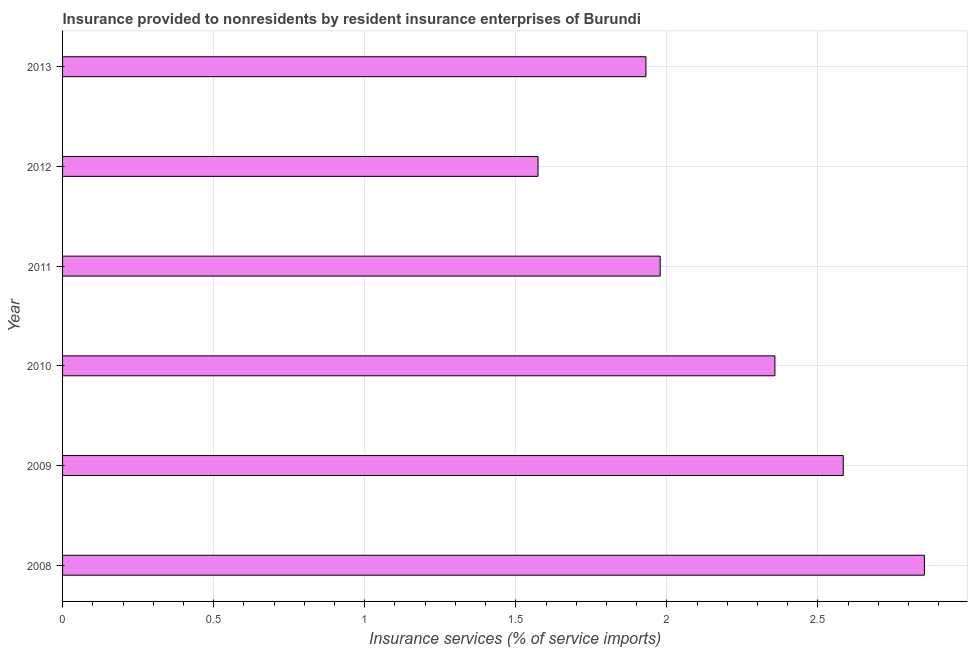Does the graph contain any zero values?
Your response must be concise. No. Does the graph contain grids?
Provide a short and direct response. Yes. What is the title of the graph?
Give a very brief answer. Insurance provided to nonresidents by resident insurance enterprises of Burundi. What is the label or title of the X-axis?
Offer a terse response. Insurance services (% of service imports). What is the label or title of the Y-axis?
Offer a terse response. Year. What is the insurance and financial services in 2010?
Provide a short and direct response. 2.36. Across all years, what is the maximum insurance and financial services?
Offer a very short reply. 2.85. Across all years, what is the minimum insurance and financial services?
Keep it short and to the point. 1.57. In which year was the insurance and financial services minimum?
Keep it short and to the point. 2012. What is the sum of the insurance and financial services?
Ensure brevity in your answer.  13.28. What is the difference between the insurance and financial services in 2008 and 2012?
Provide a succinct answer. 1.28. What is the average insurance and financial services per year?
Ensure brevity in your answer.  2.21. What is the median insurance and financial services?
Ensure brevity in your answer.  2.17. In how many years, is the insurance and financial services greater than 2.4 %?
Offer a terse response. 2. What is the ratio of the insurance and financial services in 2008 to that in 2013?
Provide a succinct answer. 1.48. Is the insurance and financial services in 2009 less than that in 2010?
Your answer should be compact. No. Is the difference between the insurance and financial services in 2009 and 2012 greater than the difference between any two years?
Keep it short and to the point. No. What is the difference between the highest and the second highest insurance and financial services?
Offer a terse response. 0.27. Is the sum of the insurance and financial services in 2009 and 2012 greater than the maximum insurance and financial services across all years?
Your answer should be very brief. Yes. What is the difference between the highest and the lowest insurance and financial services?
Ensure brevity in your answer.  1.28. In how many years, is the insurance and financial services greater than the average insurance and financial services taken over all years?
Your answer should be compact. 3. How many years are there in the graph?
Your answer should be very brief. 6. Are the values on the major ticks of X-axis written in scientific E-notation?
Provide a short and direct response. No. What is the Insurance services (% of service imports) in 2008?
Give a very brief answer. 2.85. What is the Insurance services (% of service imports) of 2009?
Make the answer very short. 2.58. What is the Insurance services (% of service imports) of 2010?
Your answer should be very brief. 2.36. What is the Insurance services (% of service imports) of 2011?
Provide a succinct answer. 1.98. What is the Insurance services (% of service imports) of 2012?
Your answer should be very brief. 1.57. What is the Insurance services (% of service imports) of 2013?
Your response must be concise. 1.93. What is the difference between the Insurance services (% of service imports) in 2008 and 2009?
Your response must be concise. 0.27. What is the difference between the Insurance services (% of service imports) in 2008 and 2010?
Ensure brevity in your answer.  0.49. What is the difference between the Insurance services (% of service imports) in 2008 and 2011?
Your answer should be very brief. 0.87. What is the difference between the Insurance services (% of service imports) in 2008 and 2012?
Provide a succinct answer. 1.28. What is the difference between the Insurance services (% of service imports) in 2008 and 2013?
Provide a short and direct response. 0.92. What is the difference between the Insurance services (% of service imports) in 2009 and 2010?
Your response must be concise. 0.23. What is the difference between the Insurance services (% of service imports) in 2009 and 2011?
Your answer should be very brief. 0.61. What is the difference between the Insurance services (% of service imports) in 2009 and 2012?
Offer a very short reply. 1.01. What is the difference between the Insurance services (% of service imports) in 2009 and 2013?
Offer a very short reply. 0.65. What is the difference between the Insurance services (% of service imports) in 2010 and 2011?
Ensure brevity in your answer.  0.38. What is the difference between the Insurance services (% of service imports) in 2010 and 2012?
Offer a very short reply. 0.78. What is the difference between the Insurance services (% of service imports) in 2010 and 2013?
Offer a terse response. 0.43. What is the difference between the Insurance services (% of service imports) in 2011 and 2012?
Give a very brief answer. 0.4. What is the difference between the Insurance services (% of service imports) in 2011 and 2013?
Your answer should be very brief. 0.05. What is the difference between the Insurance services (% of service imports) in 2012 and 2013?
Offer a terse response. -0.36. What is the ratio of the Insurance services (% of service imports) in 2008 to that in 2009?
Give a very brief answer. 1.1. What is the ratio of the Insurance services (% of service imports) in 2008 to that in 2010?
Your response must be concise. 1.21. What is the ratio of the Insurance services (% of service imports) in 2008 to that in 2011?
Provide a succinct answer. 1.44. What is the ratio of the Insurance services (% of service imports) in 2008 to that in 2012?
Offer a terse response. 1.81. What is the ratio of the Insurance services (% of service imports) in 2008 to that in 2013?
Offer a very short reply. 1.48. What is the ratio of the Insurance services (% of service imports) in 2009 to that in 2010?
Your response must be concise. 1.1. What is the ratio of the Insurance services (% of service imports) in 2009 to that in 2011?
Provide a succinct answer. 1.31. What is the ratio of the Insurance services (% of service imports) in 2009 to that in 2012?
Your response must be concise. 1.64. What is the ratio of the Insurance services (% of service imports) in 2009 to that in 2013?
Your answer should be compact. 1.34. What is the ratio of the Insurance services (% of service imports) in 2010 to that in 2011?
Make the answer very short. 1.19. What is the ratio of the Insurance services (% of service imports) in 2010 to that in 2012?
Provide a succinct answer. 1.5. What is the ratio of the Insurance services (% of service imports) in 2010 to that in 2013?
Offer a very short reply. 1.22. What is the ratio of the Insurance services (% of service imports) in 2011 to that in 2012?
Keep it short and to the point. 1.26. What is the ratio of the Insurance services (% of service imports) in 2012 to that in 2013?
Offer a very short reply. 0.81. 